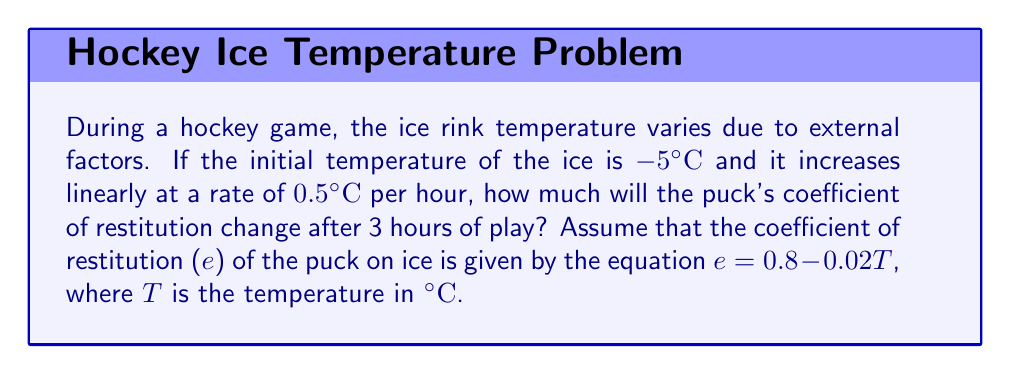Help me with this question. 1. Calculate the temperature change over 3 hours:
   Rate of temperature increase = 0.5°C/hour
   Time elapsed = 3 hours
   Temperature change = 0.5°C/hour × 3 hours = 1.5°C

2. Calculate the final temperature:
   Initial temperature = -5°C
   Final temperature = -5°C + 1.5°C = -3.5°C

3. Calculate the initial coefficient of restitution:
   $e_initial = 0.8 - 0.02T_{initial}$
   $e_initial = 0.8 - 0.02(-5) = 0.8 + 0.1 = 0.9$

4. Calculate the final coefficient of restitution:
   $e_final = 0.8 - 0.02T_{final}$
   $e_final = 0.8 - 0.02(-3.5) = 0.8 + 0.07 = 0.87$

5. Calculate the change in coefficient of restitution:
   $\Delta e = e_{final} - e_{initial}$
   $\Delta e = 0.87 - 0.9 = -0.03$

The negative value indicates a decrease in the coefficient of restitution.
Answer: -0.03 